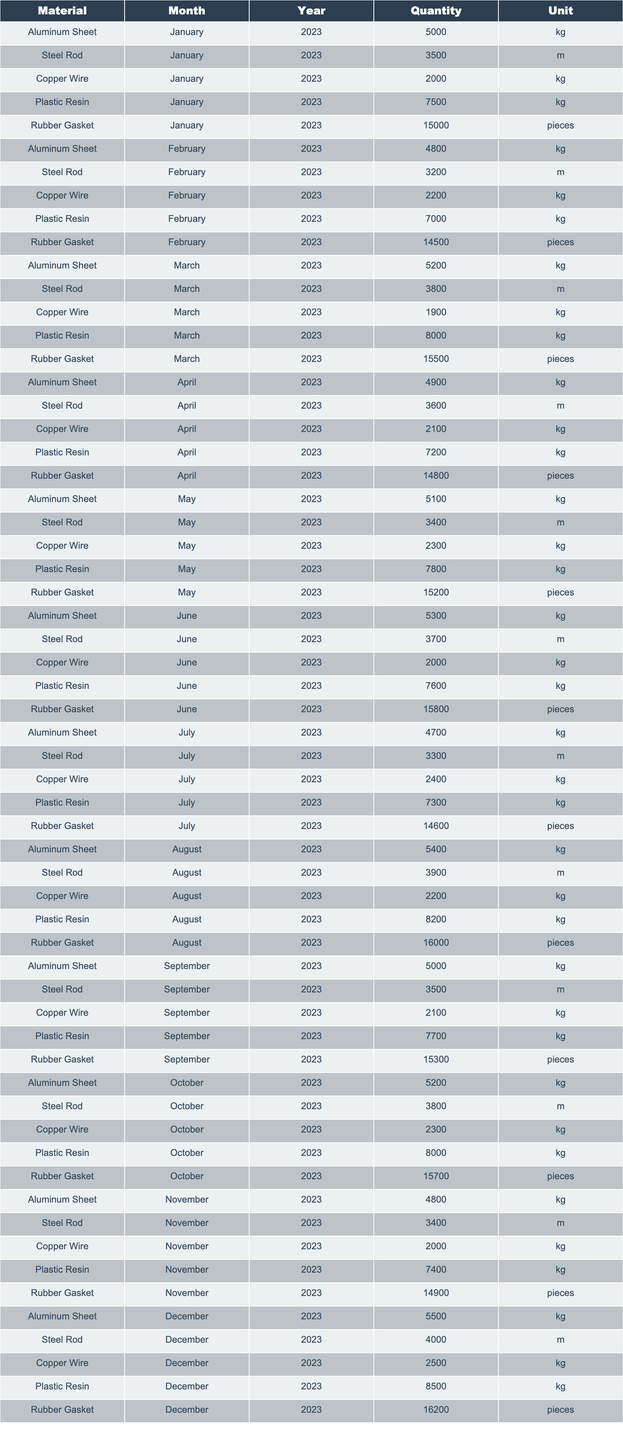what was the quantity of Steel Rods in March 2023? In the table, I locate the row for Steel Rod in March 2023, which lists a quantity of 3800 meters.
Answer: 3800 m what is the total quantity of Copper Wire used over the year 2023? I sum the quantities of Copper Wire from each month: (2000 + 2200 + 1900 + 2100 + 2300 + 2000 + 2400 + 2200 + 2100 + 2300 + 2000 + 2500) = 26100 kg.
Answer: 26100 kg did the inventory of Aluminum Sheet increase from January to December 2023? January's quantity of Aluminum Sheet is 5000 kg, and December's is 5500 kg. Since 5500 kg > 5000 kg, the inventory did increase.
Answer: Yes what was the highest recorded quantity of Plastic Resin in any month of 2023? I check the quantities of Plastic Resin in each month, finding that the highest quantity was in August 2023 with 8200 kg.
Answer: 8200 kg what is the average quantity of Rubber Gaskets for the months from January to June 2023? I find the quantities from January to June for Rubber Gaskets: (15000 + 14500 + 15500 + 14800 + 15200 + 15800). Summing these gives 91800; dividing by 6 months gives an average of 15300.
Answer: 15300 pieces how does the total quantity of Aluminum Sheets in the second half of 2023 compare to the first half? I find the total for the first half: (5000 + 4800 + 5200 + 4900 + 5100 + 5300) = 30300 kg, and for the second half: (5400 + 5000 + 5200 + 4800 + 5500) = 26300 kg. Since 30300 kg > 26300 kg, the first half has more.
Answer: First half has more what is the difference between the highest and lowest quantity of Steel Rods recorded in 2023? The highest was 3900 m in August, and the lowest was 3200 m in February. The difference is 3900 - 3200 = 700 m.
Answer: 700 m which month saw the highest quantity of Plastic Resin? From the data, I can see that August had the highest quantity of Plastic Resin recorded at 8200 kg.
Answer: August was there a month in 2023 where the quantity of Copper Wire was less than 2000 kg? Yes, January shows a quantity of 2000 kg, but no month recorded less, therefore the answer is no.
Answer: No what are the total quantities of all raw materials combined for December 2023? I sum the quantities for December: Aluminum Sheet (5500 kg) + Steel Rod (4000 m) + Copper Wire (2500 kg) + Plastic Resin (8500 kg) + Rubber Gasket (16200 pieces) = (5500 + 4000 + 2500 + 8500 + 16200) = 16200 if all are converted uniformly to kg.
Answer: 16200 kg 